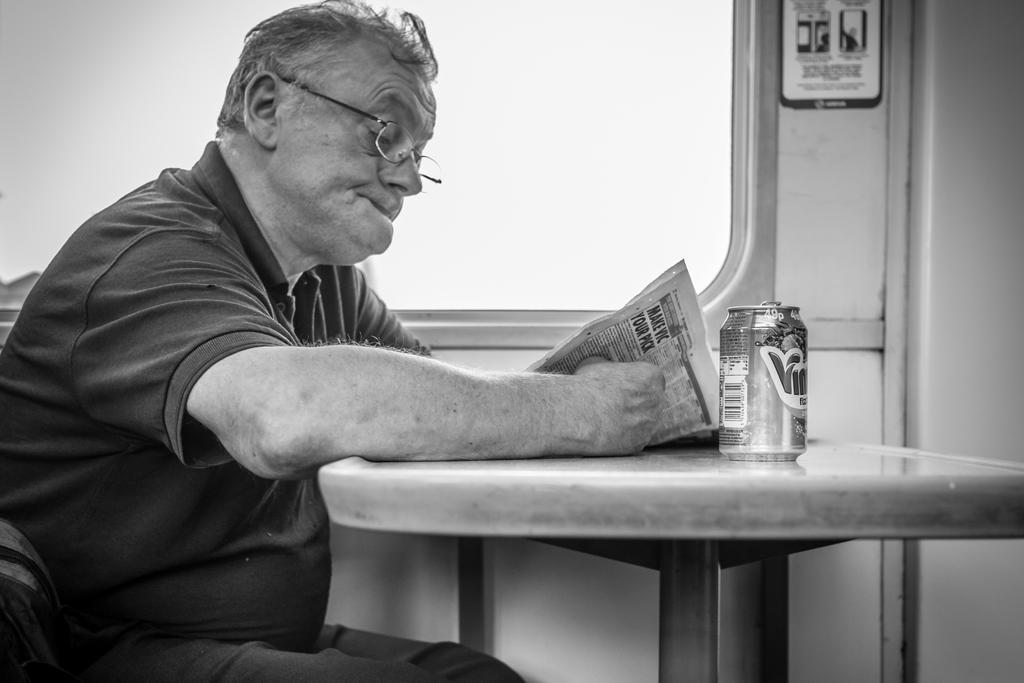In one or two sentences, can you explain what this image depicts? There is a person in a t-shirt holding newspaper, keeping hand on a table on which, there is a tin and sitting on a chair. In the background, there is a glass window near a poster which is pasted on the wall. 